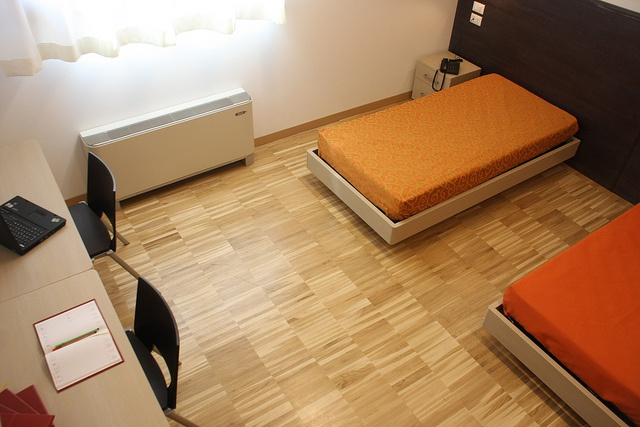Describe the objects in this image and their specific colors. I can see bed in lightgray, red, orange, and maroon tones, bed in lightgray, brown, red, and maroon tones, book in lightgray, tan, and maroon tones, chair in lightgray, black, maroon, and gray tones, and chair in lightgray, black, maroon, and gray tones in this image. 